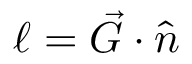<formula> <loc_0><loc_0><loc_500><loc_500>\ell = \vec { G } \cdot \hat { n }</formula> 